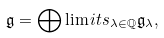Convert formula to latex. <formula><loc_0><loc_0><loc_500><loc_500>\mathfrak { g } = \bigoplus \lim i t s _ { \lambda \in \mathbb { Q } } \mathfrak { g } _ { \lambda } ,</formula> 